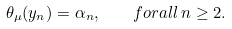Convert formula to latex. <formula><loc_0><loc_0><loc_500><loc_500>\theta _ { \mu } ( y _ { n } ) = \alpha _ { n } , \quad f o r a l l \, n \geq 2 .</formula> 